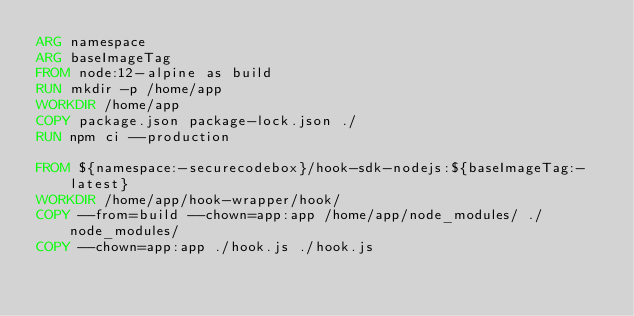Convert code to text. <code><loc_0><loc_0><loc_500><loc_500><_Dockerfile_>ARG namespace
ARG baseImageTag
FROM node:12-alpine as build
RUN mkdir -p /home/app
WORKDIR /home/app
COPY package.json package-lock.json ./
RUN npm ci --production

FROM ${namespace:-securecodebox}/hook-sdk-nodejs:${baseImageTag:-latest}
WORKDIR /home/app/hook-wrapper/hook/
COPY --from=build --chown=app:app /home/app/node_modules/ ./node_modules/
COPY --chown=app:app ./hook.js ./hook.js
</code> 